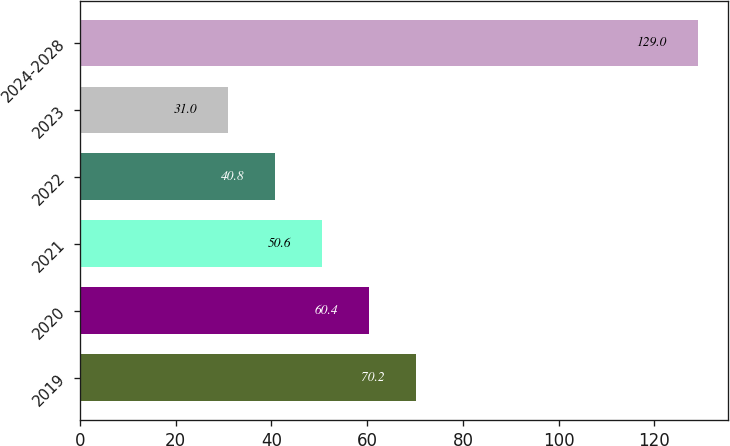Convert chart. <chart><loc_0><loc_0><loc_500><loc_500><bar_chart><fcel>2019<fcel>2020<fcel>2021<fcel>2022<fcel>2023<fcel>2024-2028<nl><fcel>70.2<fcel>60.4<fcel>50.6<fcel>40.8<fcel>31<fcel>129<nl></chart> 